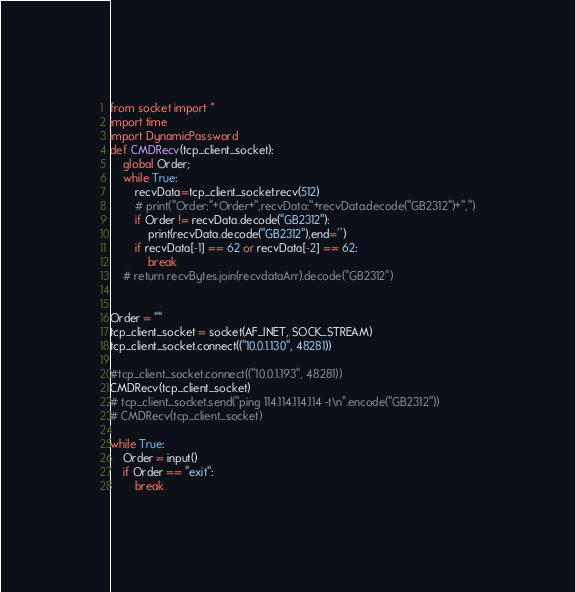<code> <loc_0><loc_0><loc_500><loc_500><_Python_>from socket import *
import time
import DynamicPassword
def CMDRecv(tcp_client_socket):
    global Order;
    while True:
        recvData=tcp_client_socket.recv(512)
        # print("Order:"+Order+",recvData:"+recvData.decode("GB2312")+",")
        if Order != recvData.decode("GB2312"):
            print(recvData.decode("GB2312"),end='')
        if recvData[-1] == 62 or recvData[-2] == 62:
            break
    # return recvBytes.join(recvdataArr).decode("GB2312")
    
    
Order = ""
tcp_client_socket = socket(AF_INET, SOCK_STREAM)
tcp_client_socket.connect(("10.0.1.130", 48281))

#tcp_client_socket.connect(("10.0.1.193", 48281))
CMDRecv(tcp_client_socket)
# tcp_client_socket.send("ping 114.114.114.114 -t\n".encode("GB2312"))
# CMDRecv(tcp_client_socket)

while True:
    Order = input()
    if Order == "exit":
        break</code> 